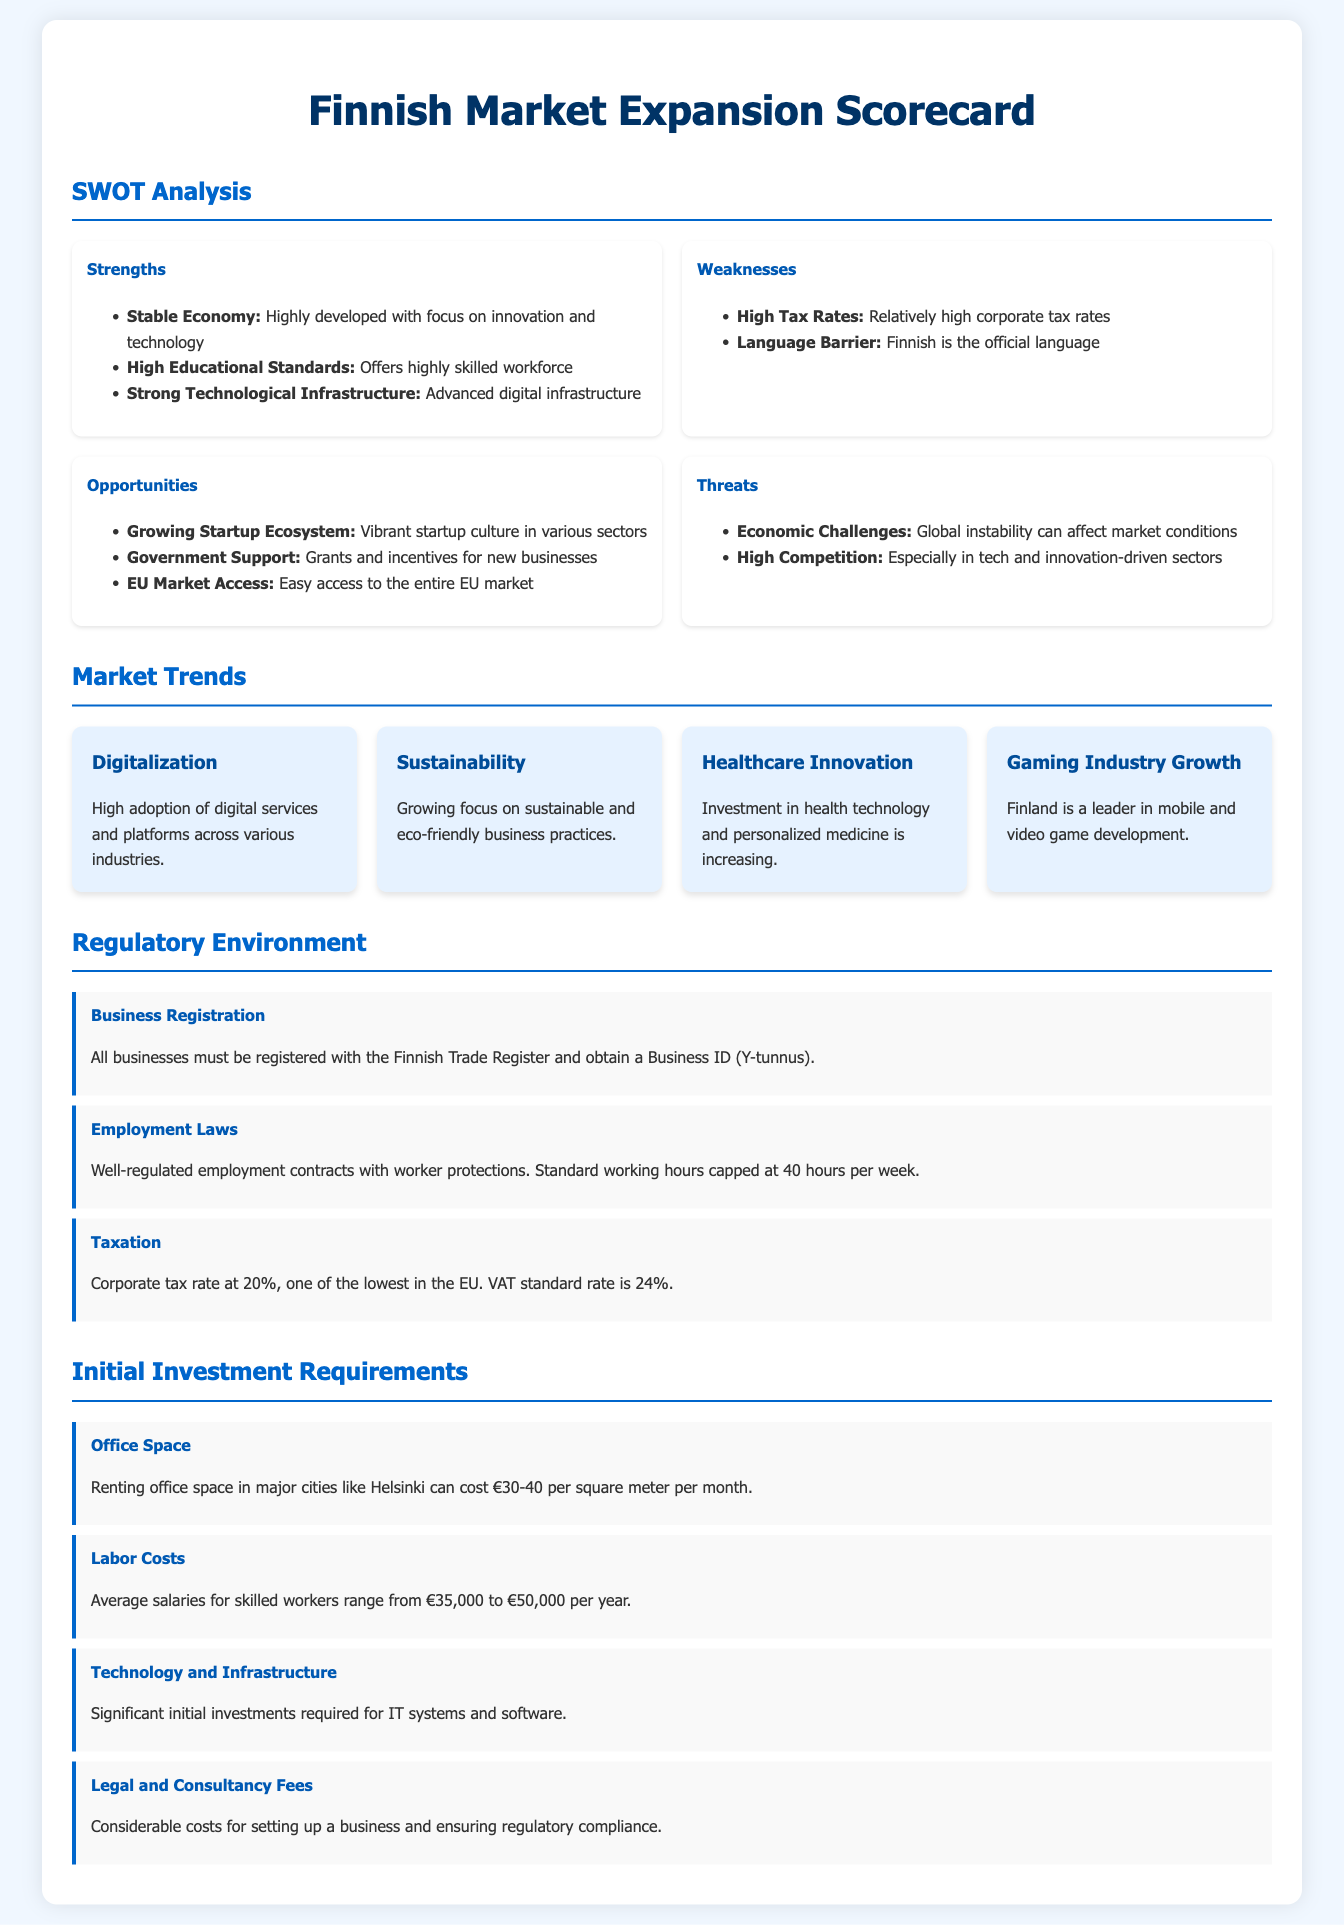What are the strengths in the SWOT analysis? The strengths are listed under the SWOT analysis section, highlighting the stable economy, high educational standards, and strong technological infrastructure.
Answer: Stable Economy, High Educational Standards, Strong Technological Infrastructure What is the corporate tax rate in Finland? The corporate tax rate is mentioned in the regulatory environment section, indicating it is relatively low compared to other EU countries.
Answer: 20% What is a significant market trend mentioned in the report? The report includes several market trends such as digitalization, sustainability, and healthcare innovation.
Answer: Digitalization What is the average annual salary range for skilled workers? The initial investment requirements section mentions the average salaries for skilled workers, which provide essential cost insights.
Answer: €35,000 to €50,000 What is a threat identified in the SWOT analysis? The threats are highlighted in the SWOT analysis section, indicating potential issues businesses may face when entering the market.
Answer: Economic Challenges How much does renting office space cost in major cities? The initial investment section indicates the monthly rental cost per square meter for office space in major Finnish cities.
Answer: €30-40 per square meter What government support is available for new businesses? The opportunities section highlights various forms of assistance from the government for startups, which is crucial for potential investors.
Answer: Grants and incentives What is a requirement for business registration in Finland? The regulatory environment section states that all businesses must have a specific registration process to operate legally in Finland.
Answer: Business ID (Y-tunnus) What is the focus of the growing startup ecosystem in Finland? The opportunities in the market analysis point to a vibrant startup ecosystem in various sectors that can benefit new businesses looking to expand.
Answer: Various sectors 